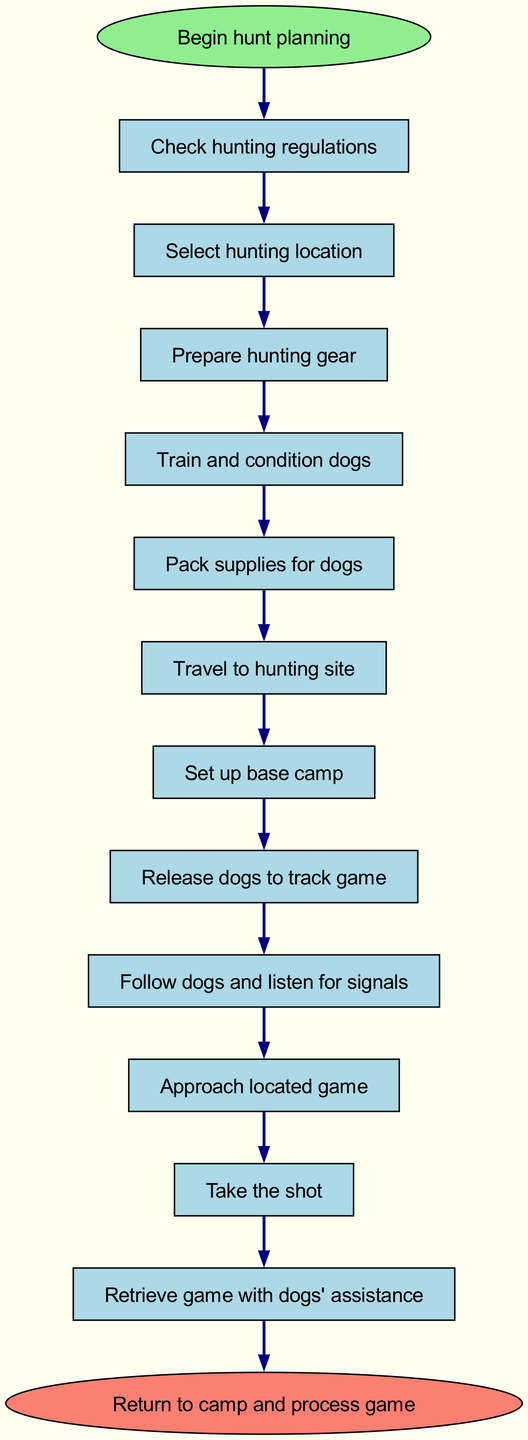What is the first step in planning the hunt? The first step is labeled "Begin hunt planning," which is the starting point of the flow chart. This indicates that all subsequent actions are contingent upon initiating this step.
Answer: Begin hunt planning How many nodes are present in the diagram? By counting all the elements provided in the data, there are 13 nodes in total, including both the start and end nodes.
Answer: 13 What do you do after checking hunting regulations? After checking hunting regulations, the next step in the flow chart is to select a hunting location, indicating the procedural direction of the planning process.
Answer: Select hunting location What step involves dogs? The steps involving dogs are "Train and condition dogs" and "Pack supplies for dogs," as they focus on preparing the dogs for the hunt.
Answer: Train and condition dogs What is the last action to be taken in the expedition? The last action in the expedition as illustrated in the flow chart is to "Return to camp and process game," which concludes the entire hunting process.
Answer: Return to camp and process game What must be done before releasing the dogs? Prior to releasing the dogs, the step "Pack supplies for dogs" must be completed, ensuring that everything necessary for the dogs is prepared.
Answer: Pack supplies for dogs What follows after retrieving the game? After retrieving the game with the assistance of the dogs, the flow chart indicates the next and final step is to return to camp and process the game, emphasizing the completion of the hunting expedition.
Answer: Return to camp and process game How many steps are there between preparing hunting gear and traveling to the hunting site? Between "Prepare hunting gear" and "Travel to hunting site," there are two steps: "Train and condition dogs" and "Pack supplies for dogs," illustrating the required preparations before moving to the hunting location.
Answer: 2 